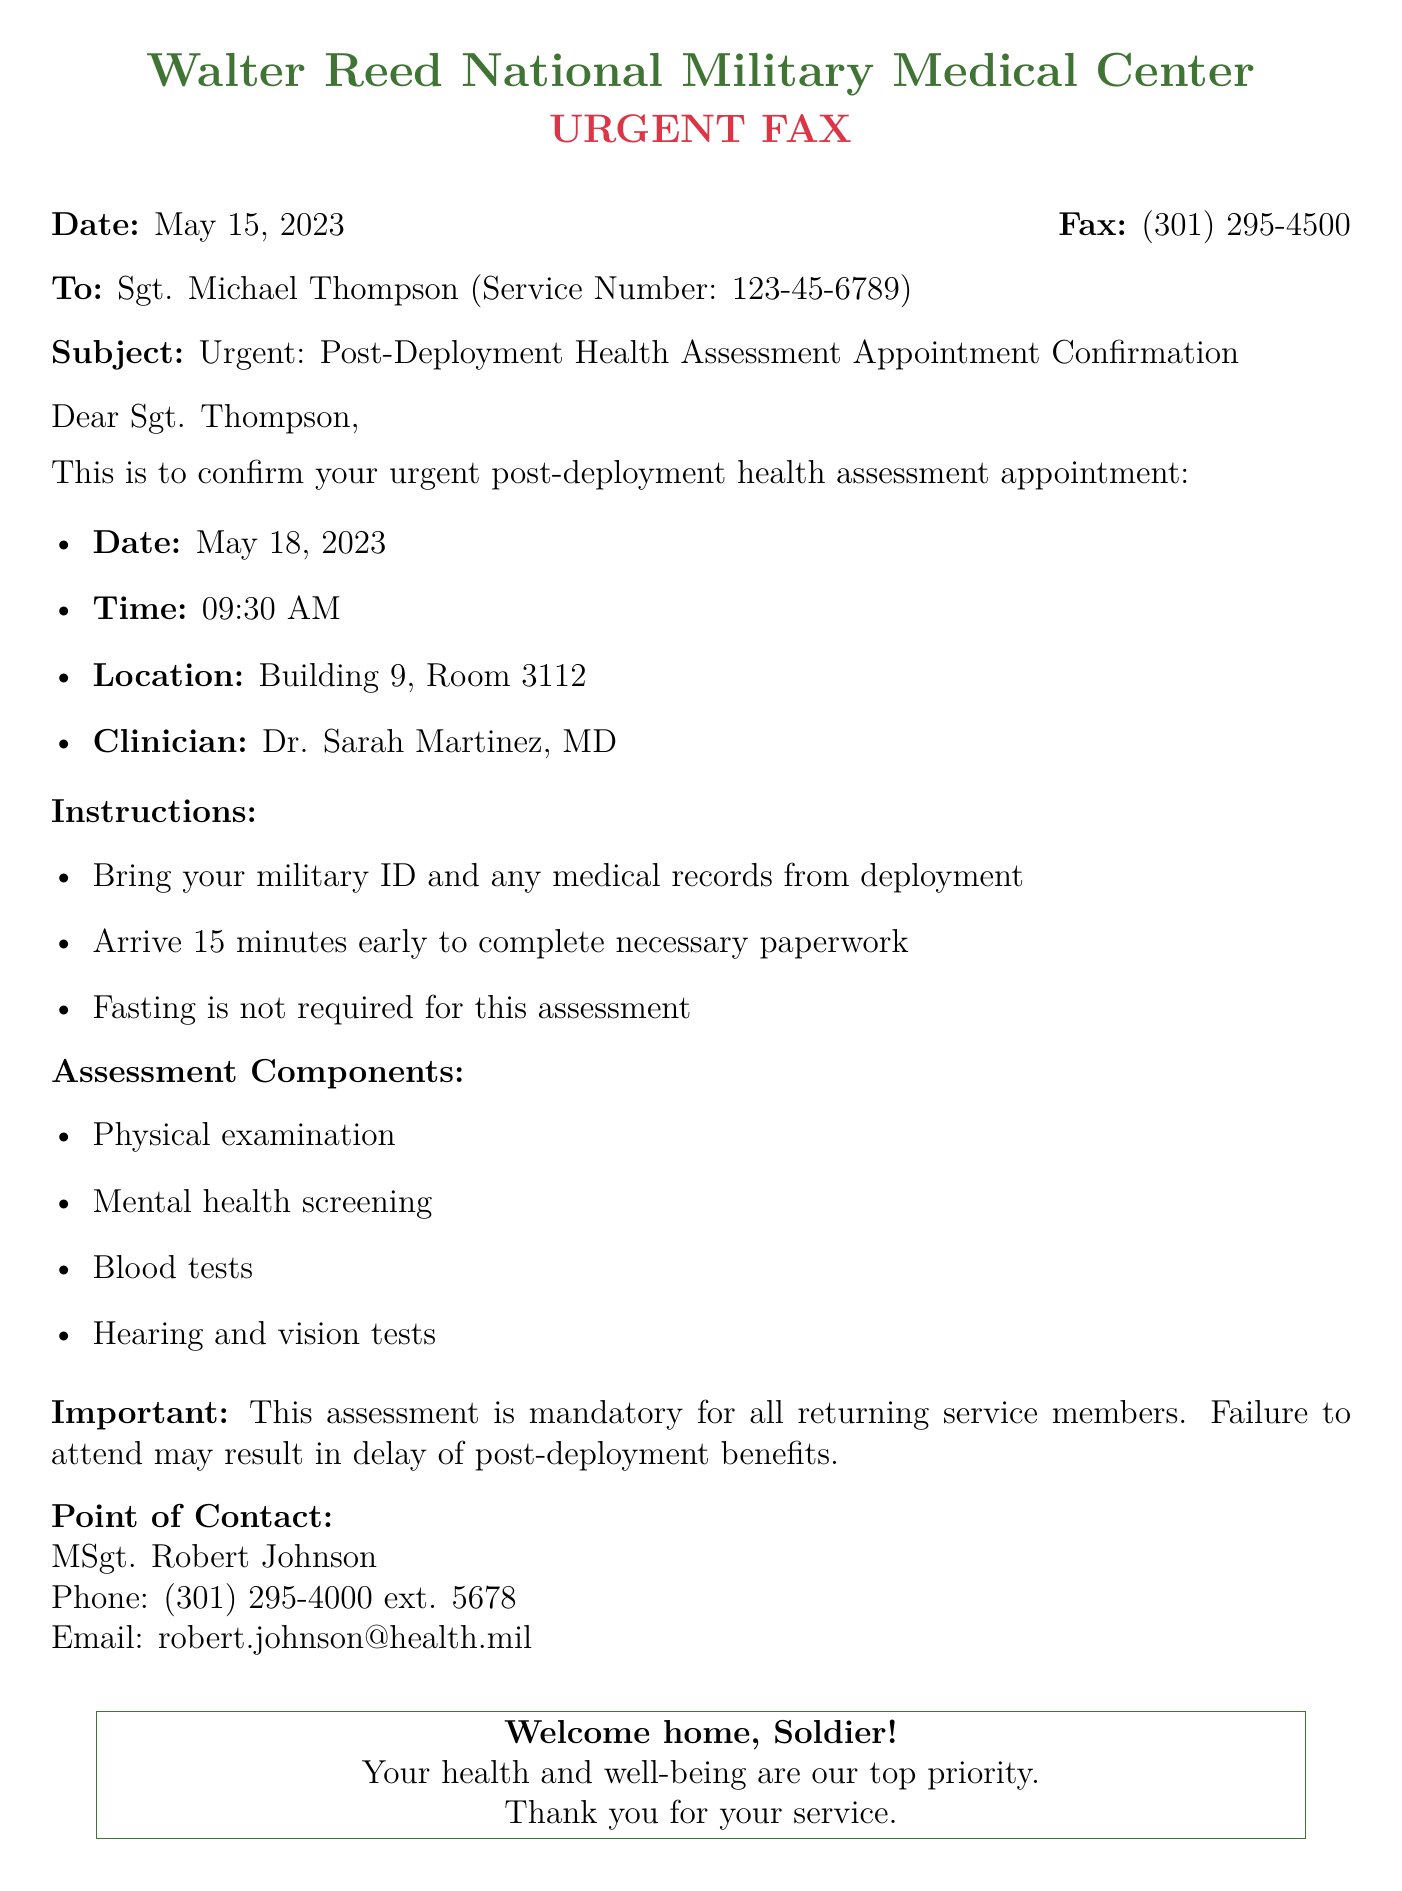What is the appointment date? The appointment date is specified in the document.
Answer: May 18, 2023 Who is the clinician for the assessment? The clinician's name is mentioned in the document.
Answer: Dr. Sarah Martinez, MD What time is the appointment scheduled for? The scheduled time for the appointment is stated in the document.
Answer: 09:30 AM What room number is designated for the assessment? The room number is provided in the appointment details.
Answer: Room 3112 What must be brought to the appointment? The document lists specific items to bring to the appointment.
Answer: Military ID and any medical records from deployment What happens if a soldier fails to attend the assessment? The document mentions consequences for not attending the assessment.
Answer: Delay of post-deployment benefits Who is the point of contact for the appointment? The name of the point of contact is provided in the document.
Answer: MSgt. Robert Johnson Is fasting required for the assessment? The document explicitly states the requirements regarding fasting.
Answer: No 